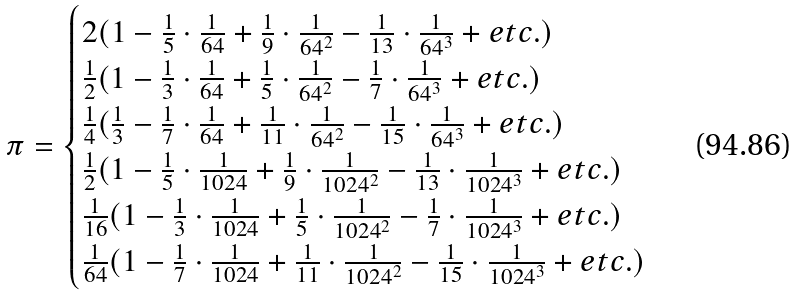<formula> <loc_0><loc_0><loc_500><loc_500>\pi = \begin{cases} 2 ( 1 - \frac { 1 } { 5 } \cdot \frac { 1 } { 6 4 } + \frac { 1 } { 9 } \cdot \frac { 1 } { 6 4 ^ { 2 } } - \frac { 1 } { 1 3 } \cdot \frac { 1 } { 6 4 ^ { 3 } } + e t c . ) \\ \frac { 1 } { 2 } ( 1 - \frac { 1 } { 3 } \cdot \frac { 1 } { 6 4 } + \frac { 1 } { 5 } \cdot \frac { 1 } { 6 4 ^ { 2 } } - \frac { 1 } { 7 } \cdot \frac { 1 } { 6 4 ^ { 3 } } + e t c . ) \\ \frac { 1 } { 4 } ( \frac { 1 } { 3 } - \frac { 1 } { 7 } \cdot \frac { 1 } { 6 4 } + \frac { 1 } { 1 1 } \cdot \frac { 1 } { 6 4 ^ { 2 } } - \frac { 1 } { 1 5 } \cdot \frac { 1 } { 6 4 ^ { 3 } } + e t c . ) \\ \frac { 1 } { 2 } ( 1 - \frac { 1 } { 5 } \cdot \frac { 1 } { 1 0 2 4 } + \frac { 1 } { 9 } \cdot \frac { 1 } { 1 0 2 4 ^ { 2 } } - \frac { 1 } { 1 3 } \cdot \frac { 1 } { 1 0 2 4 ^ { 3 } } + e t c . ) \\ \frac { 1 } { 1 6 } ( 1 - \frac { 1 } { 3 } \cdot \frac { 1 } { 1 0 2 4 } + \frac { 1 } { 5 } \cdot \frac { 1 } { 1 0 2 4 ^ { 2 } } - \frac { 1 } { 7 } \cdot \frac { 1 } { 1 0 2 4 ^ { 3 } } + e t c . ) \\ \frac { 1 } { 6 4 } ( 1 - \frac { 1 } { 7 } \cdot \frac { 1 } { 1 0 2 4 } + \frac { 1 } { 1 1 } \cdot \frac { 1 } { 1 0 2 4 ^ { 2 } } - \frac { 1 } { 1 5 } \cdot \frac { 1 } { 1 0 2 4 ^ { 3 } } + e t c . ) \end{cases}</formula> 